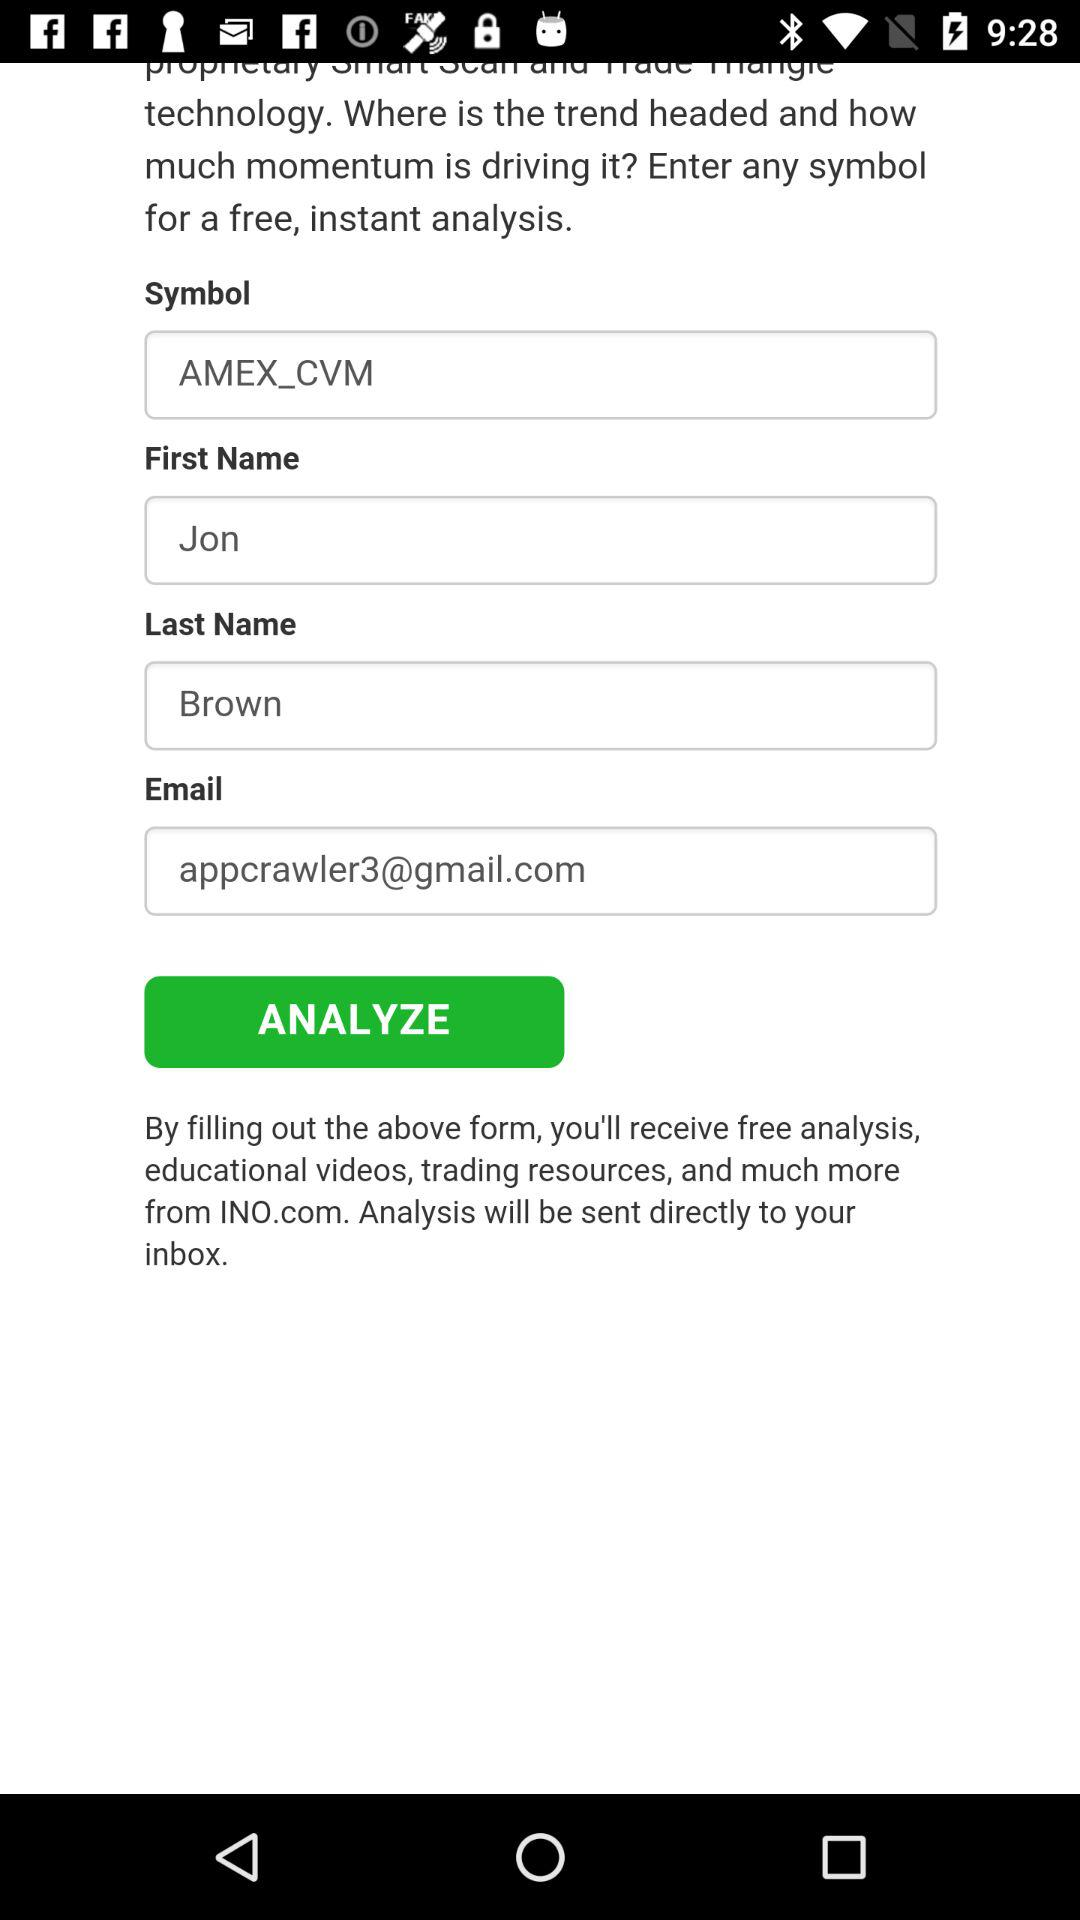What is the email address of the user? The email address is appcrawler3@gmail.com. 